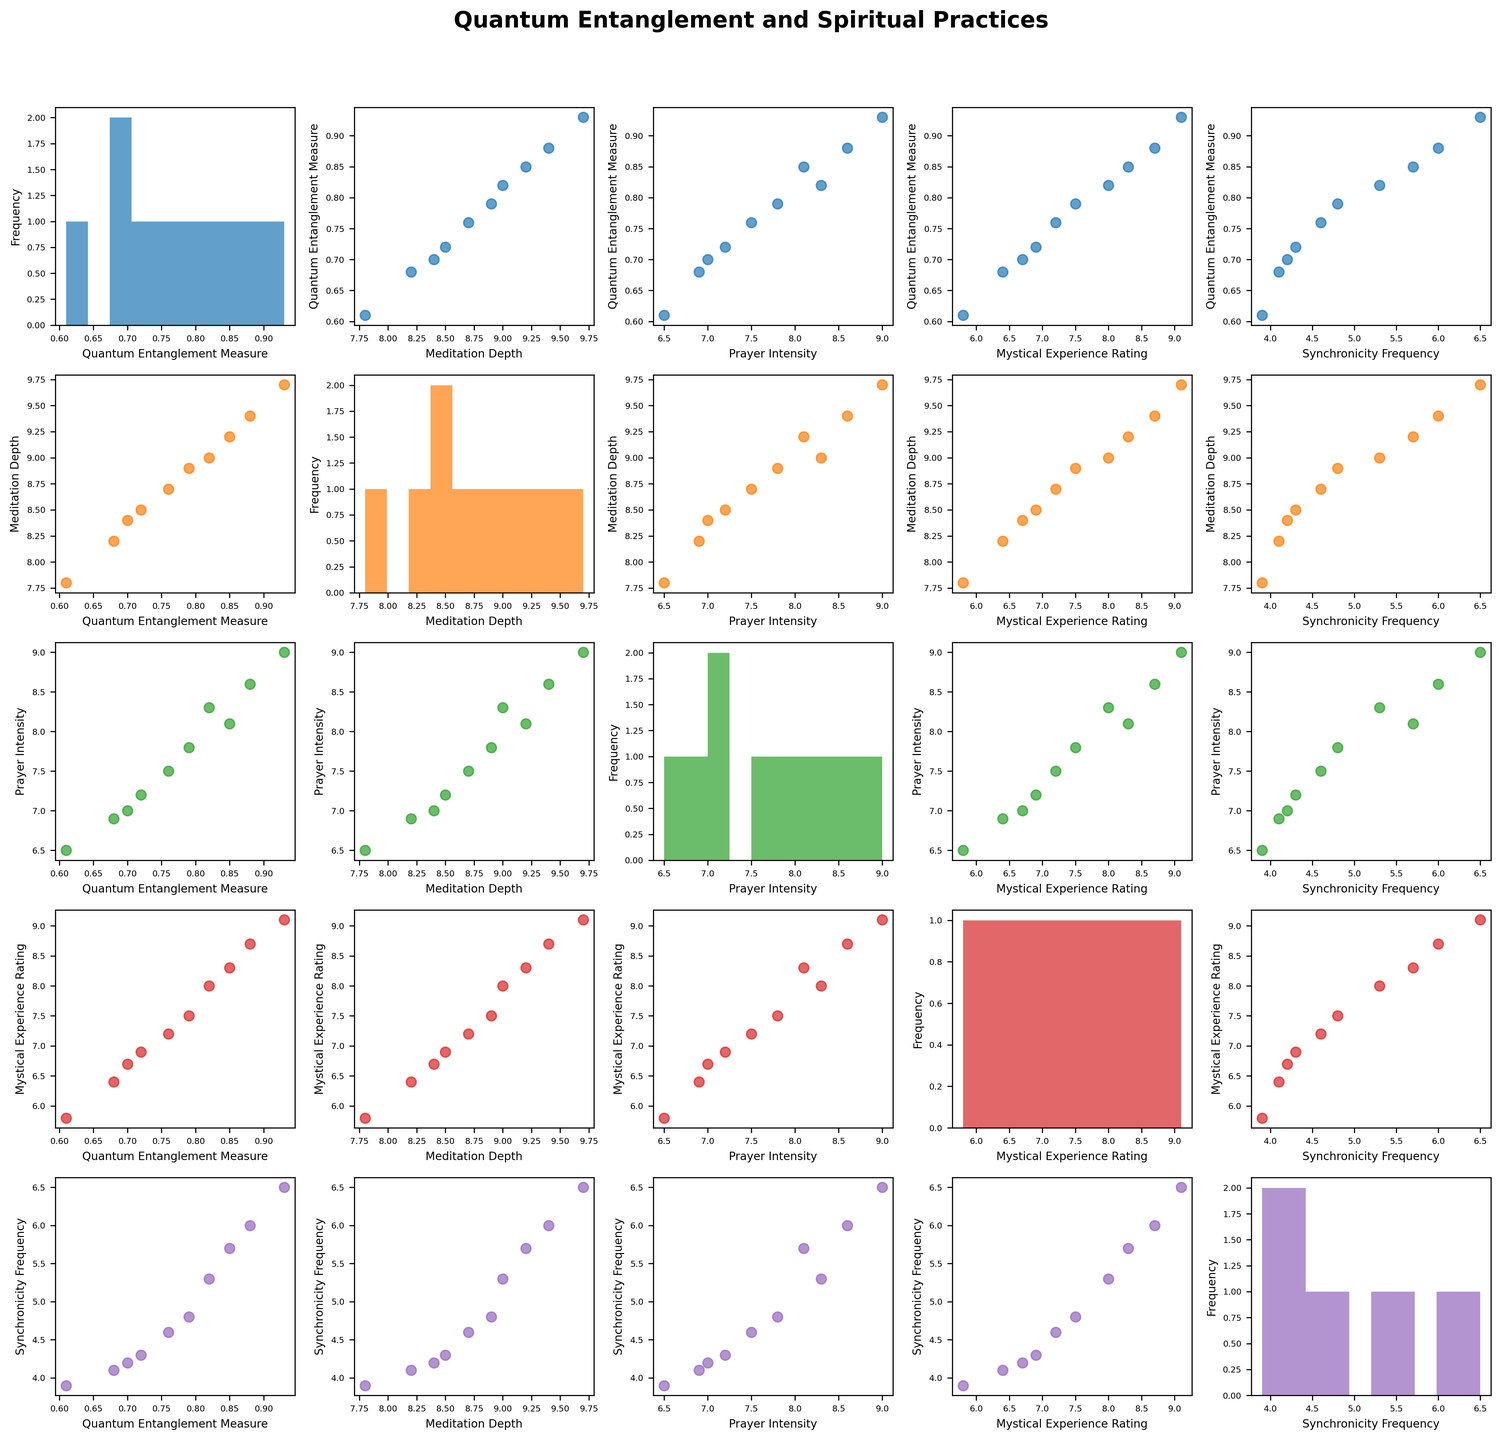What is the title of the figure? The title is located at the top of the figure in a larger, bold font. It describes what the scatterplot matrix represents.
Answer: "Quantum Entanglement and Spiritual Practices" How many variables are plotted in the scatterplot matrix? Each row and column in the matrix represents one variable. By counting the labels on either axis, we can determine the number of variables.
Answer: 5 What color is used for the scatter plot of "Quantum Entanglement Measure" vs. "Prayer Intensity"? Look at the scatter plot where the x-axis is labeled "Prayer Intensity" and the y-axis is labeled "Quantum Entanglement Measure". Note the color of the points in this scatter plot.
Answer: Blue What is the frequency of the most common "Quantum Entanglement Measure" value range in its histogram? Examine the histogram for "Quantum Entanglement Measure". Identify the bin with the highest number of data points by assessing the bar heights.
Answer: 2 Which pair of variables shows the strongest linear relationship? Check the scatterplots for pairs of variables. Look for the plot with the dots most closely forming a straight line, indicating a strong linear correlation.
Answer: "Quantum Entanglement Measure" and "Prayer Intensity" Which variable has the highest reported values on average? Compare the scatter plots or histograms. Determine the variable with data points generally located at higher values across the scatterplot matrix.
Answer: "Prayer Intensity" What is the typical shape of the distribution for "Mystical Experience Rating"? Look at the histogram for "Mystical Experience Rating". Analyze the shape of the bars to determine whether it looks normal, skewed, uniform, etc.
Answer: Skewed to the right In which range do most "Quantum Entanglement Measure" values lie? Look at the histogram for "Quantum Entanglement Measure". Identify the range where the majority of the data points are concentrated.
Answer: Between 0.7 and 0.9 Is there a clear relationship between "Meditation Depth" and "Synchronicity Frequency"? Examine the scatter plot where "Meditation Depth" is on one axis and "Synchronicity Frequency" is on the other. Assess whether the points form any discernible pattern.
Answer: No clear relationship Compare the spread of data points: Is "Meditation Depth" more variable than "Quantum Entanglement Measure"? Look at the histograms and scatterplots. Identify which variable has a wider range or greater spread of values.
Answer: "Meditation Depth" is more variable 